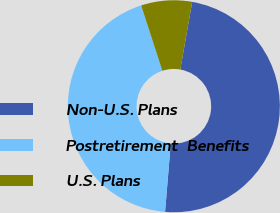<chart> <loc_0><loc_0><loc_500><loc_500><pie_chart><fcel>Non-U.S. Plans<fcel>Postretirement  Benefits<fcel>U.S. Plans<nl><fcel>48.55%<fcel>43.69%<fcel>7.76%<nl></chart> 